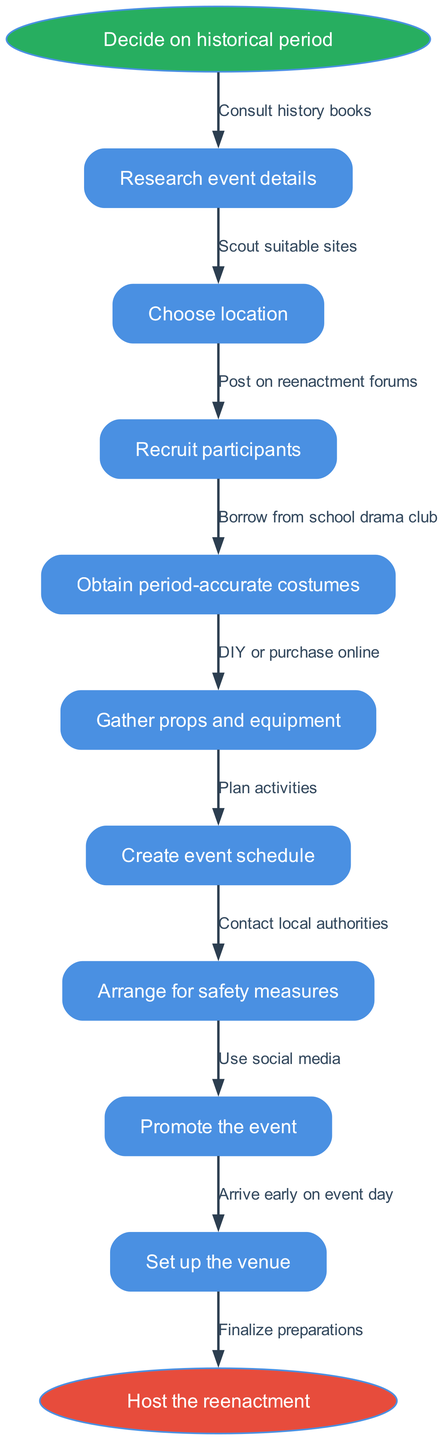What is the first step in the process? The diagram indicates that the first step is to "Decide on historical period," which is represented as the initial node.
Answer: Decide on historical period How many nodes are in the diagram? There are nine nodes, categorized into one start, seven intermediate nodes, and one end node. Each node represents a step in the process.
Answer: Nine What is the last step before hosting the reenactment? The last step before hosting the event is to "Set up the venue," which is the last intermediate node in the process before reaching the end node.
Answer: Set up the venue What process follows after "Research event details"? Following "Research event details," the next step in the flow chart is "Choose location," which is directly connected to the first intermediate node.
Answer: Choose location Which step involves contacting local authorities? The step where local authorities are contacted is "Arrange for safety measures," which is specified as a necessary step before hosting the reenactment event.
Answer: Arrange for safety measures What is the relationship between "Gather props and equipment" and "Obtain period-accurate costumes"? In the flow of the diagram, "Obtain period-accurate costumes" comes directly before "Gather props and equipment," indicating that the costuming step precedes gathering props in the process.
Answer: Sequential What is used to promote the event? The diagram specifies that social media is used for promoting the event, highlighting its importance in outreach for historical reenactments.
Answer: Social media What is indicated as a potential source for obtaining costumes? The diagram mentions borrowing from the school drama club as a potential source for obtaining period-accurate costumes, showcasing a community resource.
Answer: School drama club What is the ultimate goal of the diagram? The ultimate goal of the flowchart is to "Host the reenactment," which is represented as the final state of the process after all preparations.
Answer: Host the reenactment 